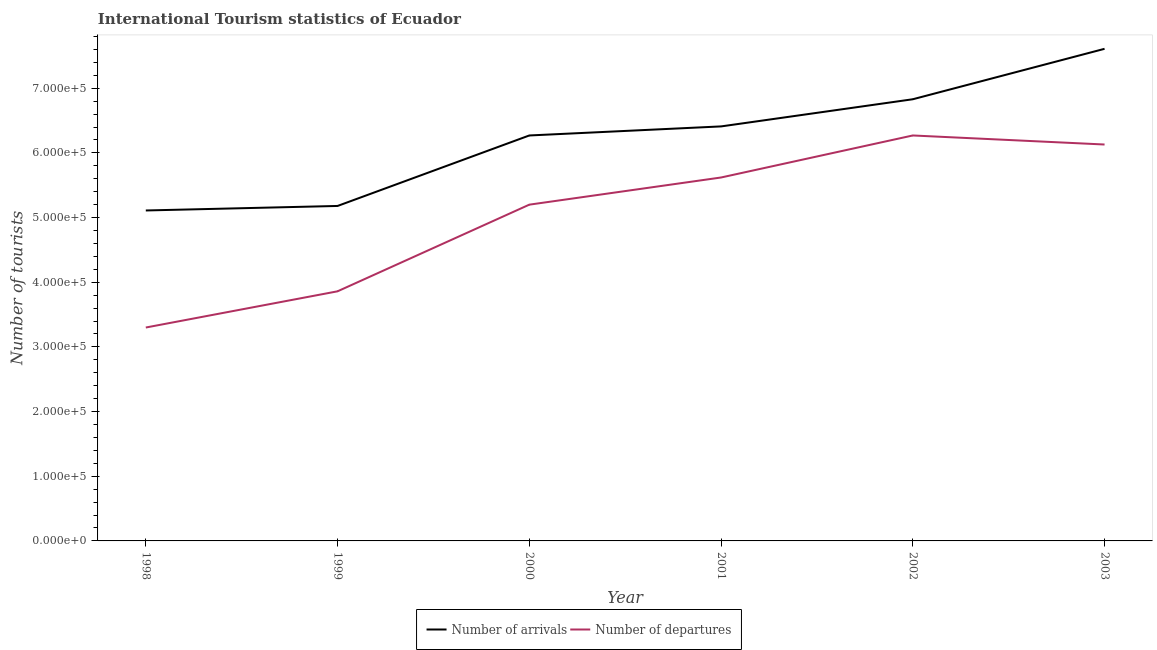Does the line corresponding to number of tourist departures intersect with the line corresponding to number of tourist arrivals?
Keep it short and to the point. No. Is the number of lines equal to the number of legend labels?
Your answer should be compact. Yes. What is the number of tourist departures in 1998?
Provide a succinct answer. 3.30e+05. Across all years, what is the maximum number of tourist departures?
Keep it short and to the point. 6.27e+05. Across all years, what is the minimum number of tourist departures?
Give a very brief answer. 3.30e+05. In which year was the number of tourist arrivals maximum?
Offer a terse response. 2003. What is the total number of tourist departures in the graph?
Provide a short and direct response. 3.04e+06. What is the difference between the number of tourist arrivals in 2000 and that in 2002?
Provide a short and direct response. -5.60e+04. What is the difference between the number of tourist arrivals in 1999 and the number of tourist departures in 2002?
Offer a very short reply. -1.09e+05. What is the average number of tourist departures per year?
Provide a short and direct response. 5.06e+05. In the year 2000, what is the difference between the number of tourist arrivals and number of tourist departures?
Provide a succinct answer. 1.07e+05. What is the ratio of the number of tourist departures in 2000 to that in 2002?
Offer a terse response. 0.83. Is the number of tourist arrivals in 2000 less than that in 2001?
Give a very brief answer. Yes. What is the difference between the highest and the second highest number of tourist departures?
Offer a terse response. 1.40e+04. What is the difference between the highest and the lowest number of tourist departures?
Your answer should be compact. 2.97e+05. Is the number of tourist arrivals strictly greater than the number of tourist departures over the years?
Offer a very short reply. Yes. How many lines are there?
Ensure brevity in your answer.  2. What is the difference between two consecutive major ticks on the Y-axis?
Your response must be concise. 1.00e+05. Does the graph contain grids?
Your answer should be compact. No. How many legend labels are there?
Provide a succinct answer. 2. What is the title of the graph?
Your answer should be very brief. International Tourism statistics of Ecuador. What is the label or title of the X-axis?
Offer a terse response. Year. What is the label or title of the Y-axis?
Provide a short and direct response. Number of tourists. What is the Number of tourists in Number of arrivals in 1998?
Make the answer very short. 5.11e+05. What is the Number of tourists in Number of departures in 1998?
Provide a short and direct response. 3.30e+05. What is the Number of tourists of Number of arrivals in 1999?
Your answer should be compact. 5.18e+05. What is the Number of tourists in Number of departures in 1999?
Your answer should be very brief. 3.86e+05. What is the Number of tourists of Number of arrivals in 2000?
Keep it short and to the point. 6.27e+05. What is the Number of tourists of Number of departures in 2000?
Your answer should be very brief. 5.20e+05. What is the Number of tourists in Number of arrivals in 2001?
Your answer should be compact. 6.41e+05. What is the Number of tourists of Number of departures in 2001?
Your response must be concise. 5.62e+05. What is the Number of tourists in Number of arrivals in 2002?
Your response must be concise. 6.83e+05. What is the Number of tourists in Number of departures in 2002?
Your response must be concise. 6.27e+05. What is the Number of tourists of Number of arrivals in 2003?
Offer a very short reply. 7.61e+05. What is the Number of tourists in Number of departures in 2003?
Your answer should be very brief. 6.13e+05. Across all years, what is the maximum Number of tourists of Number of arrivals?
Ensure brevity in your answer.  7.61e+05. Across all years, what is the maximum Number of tourists of Number of departures?
Ensure brevity in your answer.  6.27e+05. Across all years, what is the minimum Number of tourists in Number of arrivals?
Your answer should be compact. 5.11e+05. Across all years, what is the minimum Number of tourists of Number of departures?
Make the answer very short. 3.30e+05. What is the total Number of tourists of Number of arrivals in the graph?
Offer a terse response. 3.74e+06. What is the total Number of tourists of Number of departures in the graph?
Your answer should be very brief. 3.04e+06. What is the difference between the Number of tourists of Number of arrivals in 1998 and that in 1999?
Your answer should be very brief. -7000. What is the difference between the Number of tourists of Number of departures in 1998 and that in 1999?
Provide a short and direct response. -5.60e+04. What is the difference between the Number of tourists in Number of arrivals in 1998 and that in 2000?
Your response must be concise. -1.16e+05. What is the difference between the Number of tourists of Number of departures in 1998 and that in 2000?
Make the answer very short. -1.90e+05. What is the difference between the Number of tourists in Number of arrivals in 1998 and that in 2001?
Provide a succinct answer. -1.30e+05. What is the difference between the Number of tourists in Number of departures in 1998 and that in 2001?
Your answer should be compact. -2.32e+05. What is the difference between the Number of tourists in Number of arrivals in 1998 and that in 2002?
Provide a short and direct response. -1.72e+05. What is the difference between the Number of tourists of Number of departures in 1998 and that in 2002?
Offer a terse response. -2.97e+05. What is the difference between the Number of tourists in Number of departures in 1998 and that in 2003?
Offer a very short reply. -2.83e+05. What is the difference between the Number of tourists in Number of arrivals in 1999 and that in 2000?
Provide a succinct answer. -1.09e+05. What is the difference between the Number of tourists in Number of departures in 1999 and that in 2000?
Offer a terse response. -1.34e+05. What is the difference between the Number of tourists of Number of arrivals in 1999 and that in 2001?
Your answer should be compact. -1.23e+05. What is the difference between the Number of tourists in Number of departures in 1999 and that in 2001?
Provide a short and direct response. -1.76e+05. What is the difference between the Number of tourists of Number of arrivals in 1999 and that in 2002?
Provide a short and direct response. -1.65e+05. What is the difference between the Number of tourists in Number of departures in 1999 and that in 2002?
Give a very brief answer. -2.41e+05. What is the difference between the Number of tourists in Number of arrivals in 1999 and that in 2003?
Ensure brevity in your answer.  -2.43e+05. What is the difference between the Number of tourists in Number of departures in 1999 and that in 2003?
Your answer should be compact. -2.27e+05. What is the difference between the Number of tourists in Number of arrivals in 2000 and that in 2001?
Your answer should be very brief. -1.40e+04. What is the difference between the Number of tourists of Number of departures in 2000 and that in 2001?
Keep it short and to the point. -4.20e+04. What is the difference between the Number of tourists in Number of arrivals in 2000 and that in 2002?
Make the answer very short. -5.60e+04. What is the difference between the Number of tourists of Number of departures in 2000 and that in 2002?
Provide a succinct answer. -1.07e+05. What is the difference between the Number of tourists in Number of arrivals in 2000 and that in 2003?
Make the answer very short. -1.34e+05. What is the difference between the Number of tourists of Number of departures in 2000 and that in 2003?
Offer a terse response. -9.30e+04. What is the difference between the Number of tourists in Number of arrivals in 2001 and that in 2002?
Your answer should be compact. -4.20e+04. What is the difference between the Number of tourists in Number of departures in 2001 and that in 2002?
Your answer should be very brief. -6.50e+04. What is the difference between the Number of tourists of Number of departures in 2001 and that in 2003?
Your response must be concise. -5.10e+04. What is the difference between the Number of tourists of Number of arrivals in 2002 and that in 2003?
Your response must be concise. -7.80e+04. What is the difference between the Number of tourists of Number of departures in 2002 and that in 2003?
Offer a very short reply. 1.40e+04. What is the difference between the Number of tourists of Number of arrivals in 1998 and the Number of tourists of Number of departures in 1999?
Provide a succinct answer. 1.25e+05. What is the difference between the Number of tourists in Number of arrivals in 1998 and the Number of tourists in Number of departures in 2000?
Your answer should be very brief. -9000. What is the difference between the Number of tourists in Number of arrivals in 1998 and the Number of tourists in Number of departures in 2001?
Your answer should be compact. -5.10e+04. What is the difference between the Number of tourists in Number of arrivals in 1998 and the Number of tourists in Number of departures in 2002?
Your answer should be very brief. -1.16e+05. What is the difference between the Number of tourists in Number of arrivals in 1998 and the Number of tourists in Number of departures in 2003?
Your answer should be compact. -1.02e+05. What is the difference between the Number of tourists of Number of arrivals in 1999 and the Number of tourists of Number of departures in 2000?
Provide a succinct answer. -2000. What is the difference between the Number of tourists in Number of arrivals in 1999 and the Number of tourists in Number of departures in 2001?
Provide a succinct answer. -4.40e+04. What is the difference between the Number of tourists in Number of arrivals in 1999 and the Number of tourists in Number of departures in 2002?
Offer a terse response. -1.09e+05. What is the difference between the Number of tourists in Number of arrivals in 1999 and the Number of tourists in Number of departures in 2003?
Offer a very short reply. -9.50e+04. What is the difference between the Number of tourists in Number of arrivals in 2000 and the Number of tourists in Number of departures in 2001?
Provide a succinct answer. 6.50e+04. What is the difference between the Number of tourists in Number of arrivals in 2000 and the Number of tourists in Number of departures in 2003?
Ensure brevity in your answer.  1.40e+04. What is the difference between the Number of tourists in Number of arrivals in 2001 and the Number of tourists in Number of departures in 2002?
Keep it short and to the point. 1.40e+04. What is the difference between the Number of tourists of Number of arrivals in 2001 and the Number of tourists of Number of departures in 2003?
Your answer should be compact. 2.80e+04. What is the difference between the Number of tourists in Number of arrivals in 2002 and the Number of tourists in Number of departures in 2003?
Offer a very short reply. 7.00e+04. What is the average Number of tourists of Number of arrivals per year?
Your answer should be compact. 6.24e+05. What is the average Number of tourists of Number of departures per year?
Provide a short and direct response. 5.06e+05. In the year 1998, what is the difference between the Number of tourists of Number of arrivals and Number of tourists of Number of departures?
Provide a succinct answer. 1.81e+05. In the year 1999, what is the difference between the Number of tourists in Number of arrivals and Number of tourists in Number of departures?
Provide a short and direct response. 1.32e+05. In the year 2000, what is the difference between the Number of tourists of Number of arrivals and Number of tourists of Number of departures?
Make the answer very short. 1.07e+05. In the year 2001, what is the difference between the Number of tourists in Number of arrivals and Number of tourists in Number of departures?
Offer a terse response. 7.90e+04. In the year 2002, what is the difference between the Number of tourists in Number of arrivals and Number of tourists in Number of departures?
Ensure brevity in your answer.  5.60e+04. In the year 2003, what is the difference between the Number of tourists in Number of arrivals and Number of tourists in Number of departures?
Offer a terse response. 1.48e+05. What is the ratio of the Number of tourists of Number of arrivals in 1998 to that in 1999?
Your response must be concise. 0.99. What is the ratio of the Number of tourists of Number of departures in 1998 to that in 1999?
Keep it short and to the point. 0.85. What is the ratio of the Number of tourists of Number of arrivals in 1998 to that in 2000?
Offer a very short reply. 0.81. What is the ratio of the Number of tourists in Number of departures in 1998 to that in 2000?
Keep it short and to the point. 0.63. What is the ratio of the Number of tourists in Number of arrivals in 1998 to that in 2001?
Give a very brief answer. 0.8. What is the ratio of the Number of tourists of Number of departures in 1998 to that in 2001?
Your answer should be very brief. 0.59. What is the ratio of the Number of tourists of Number of arrivals in 1998 to that in 2002?
Provide a succinct answer. 0.75. What is the ratio of the Number of tourists of Number of departures in 1998 to that in 2002?
Offer a very short reply. 0.53. What is the ratio of the Number of tourists in Number of arrivals in 1998 to that in 2003?
Provide a succinct answer. 0.67. What is the ratio of the Number of tourists in Number of departures in 1998 to that in 2003?
Keep it short and to the point. 0.54. What is the ratio of the Number of tourists of Number of arrivals in 1999 to that in 2000?
Ensure brevity in your answer.  0.83. What is the ratio of the Number of tourists in Number of departures in 1999 to that in 2000?
Provide a short and direct response. 0.74. What is the ratio of the Number of tourists in Number of arrivals in 1999 to that in 2001?
Provide a short and direct response. 0.81. What is the ratio of the Number of tourists of Number of departures in 1999 to that in 2001?
Provide a succinct answer. 0.69. What is the ratio of the Number of tourists of Number of arrivals in 1999 to that in 2002?
Offer a terse response. 0.76. What is the ratio of the Number of tourists in Number of departures in 1999 to that in 2002?
Your response must be concise. 0.62. What is the ratio of the Number of tourists of Number of arrivals in 1999 to that in 2003?
Your response must be concise. 0.68. What is the ratio of the Number of tourists in Number of departures in 1999 to that in 2003?
Give a very brief answer. 0.63. What is the ratio of the Number of tourists in Number of arrivals in 2000 to that in 2001?
Offer a very short reply. 0.98. What is the ratio of the Number of tourists in Number of departures in 2000 to that in 2001?
Give a very brief answer. 0.93. What is the ratio of the Number of tourists in Number of arrivals in 2000 to that in 2002?
Offer a very short reply. 0.92. What is the ratio of the Number of tourists in Number of departures in 2000 to that in 2002?
Make the answer very short. 0.83. What is the ratio of the Number of tourists in Number of arrivals in 2000 to that in 2003?
Ensure brevity in your answer.  0.82. What is the ratio of the Number of tourists in Number of departures in 2000 to that in 2003?
Give a very brief answer. 0.85. What is the ratio of the Number of tourists in Number of arrivals in 2001 to that in 2002?
Make the answer very short. 0.94. What is the ratio of the Number of tourists in Number of departures in 2001 to that in 2002?
Provide a succinct answer. 0.9. What is the ratio of the Number of tourists of Number of arrivals in 2001 to that in 2003?
Provide a short and direct response. 0.84. What is the ratio of the Number of tourists in Number of departures in 2001 to that in 2003?
Your answer should be very brief. 0.92. What is the ratio of the Number of tourists in Number of arrivals in 2002 to that in 2003?
Provide a short and direct response. 0.9. What is the ratio of the Number of tourists in Number of departures in 2002 to that in 2003?
Your answer should be very brief. 1.02. What is the difference between the highest and the second highest Number of tourists of Number of arrivals?
Keep it short and to the point. 7.80e+04. What is the difference between the highest and the second highest Number of tourists in Number of departures?
Your answer should be compact. 1.40e+04. What is the difference between the highest and the lowest Number of tourists of Number of arrivals?
Provide a succinct answer. 2.50e+05. What is the difference between the highest and the lowest Number of tourists of Number of departures?
Offer a terse response. 2.97e+05. 